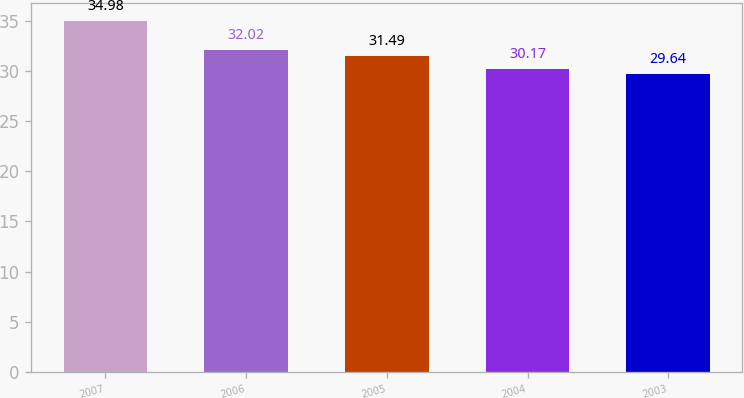<chart> <loc_0><loc_0><loc_500><loc_500><bar_chart><fcel>2007<fcel>2006<fcel>2005<fcel>2004<fcel>2003<nl><fcel>34.98<fcel>32.02<fcel>31.49<fcel>30.17<fcel>29.64<nl></chart> 